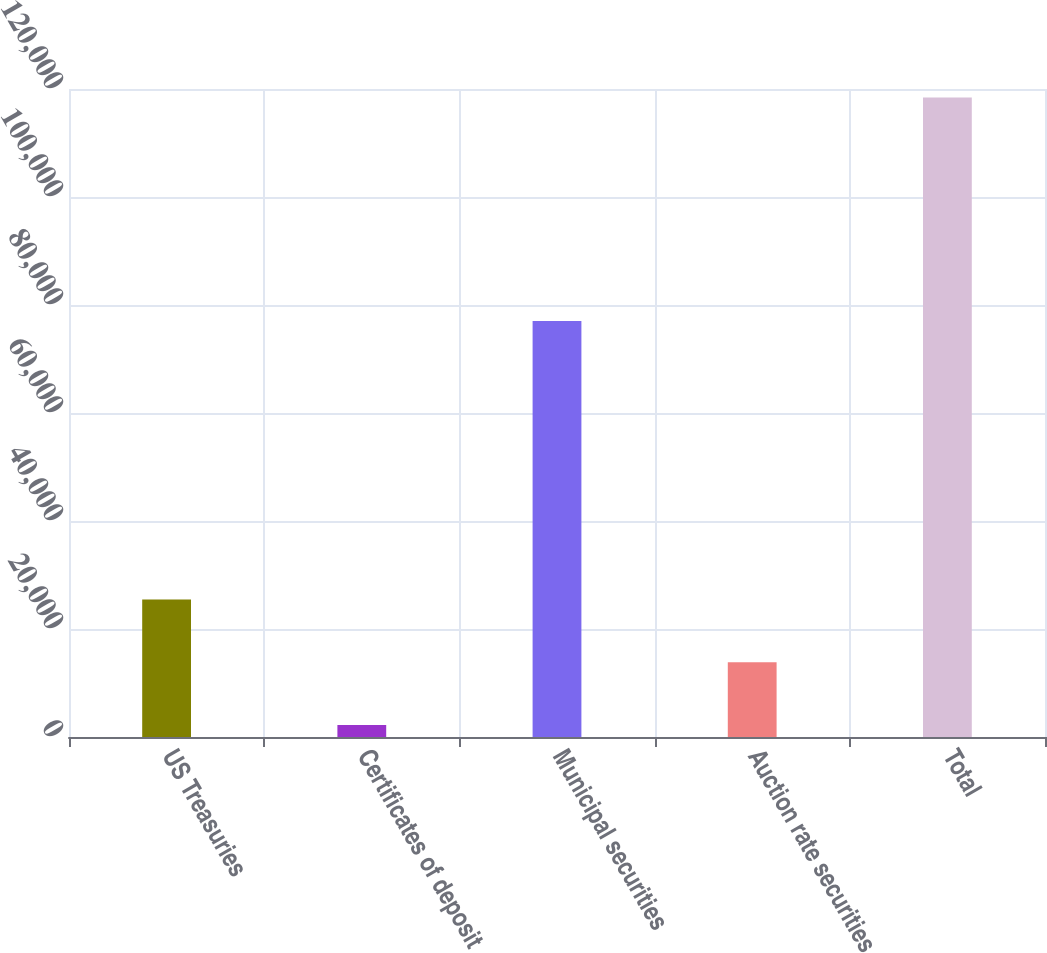Convert chart. <chart><loc_0><loc_0><loc_500><loc_500><bar_chart><fcel>US Treasuries<fcel>Certificates of deposit<fcel>Municipal securities<fcel>Auction rate securities<fcel>Total<nl><fcel>25445.6<fcel>2201<fcel>77027<fcel>13823.3<fcel>118424<nl></chart> 